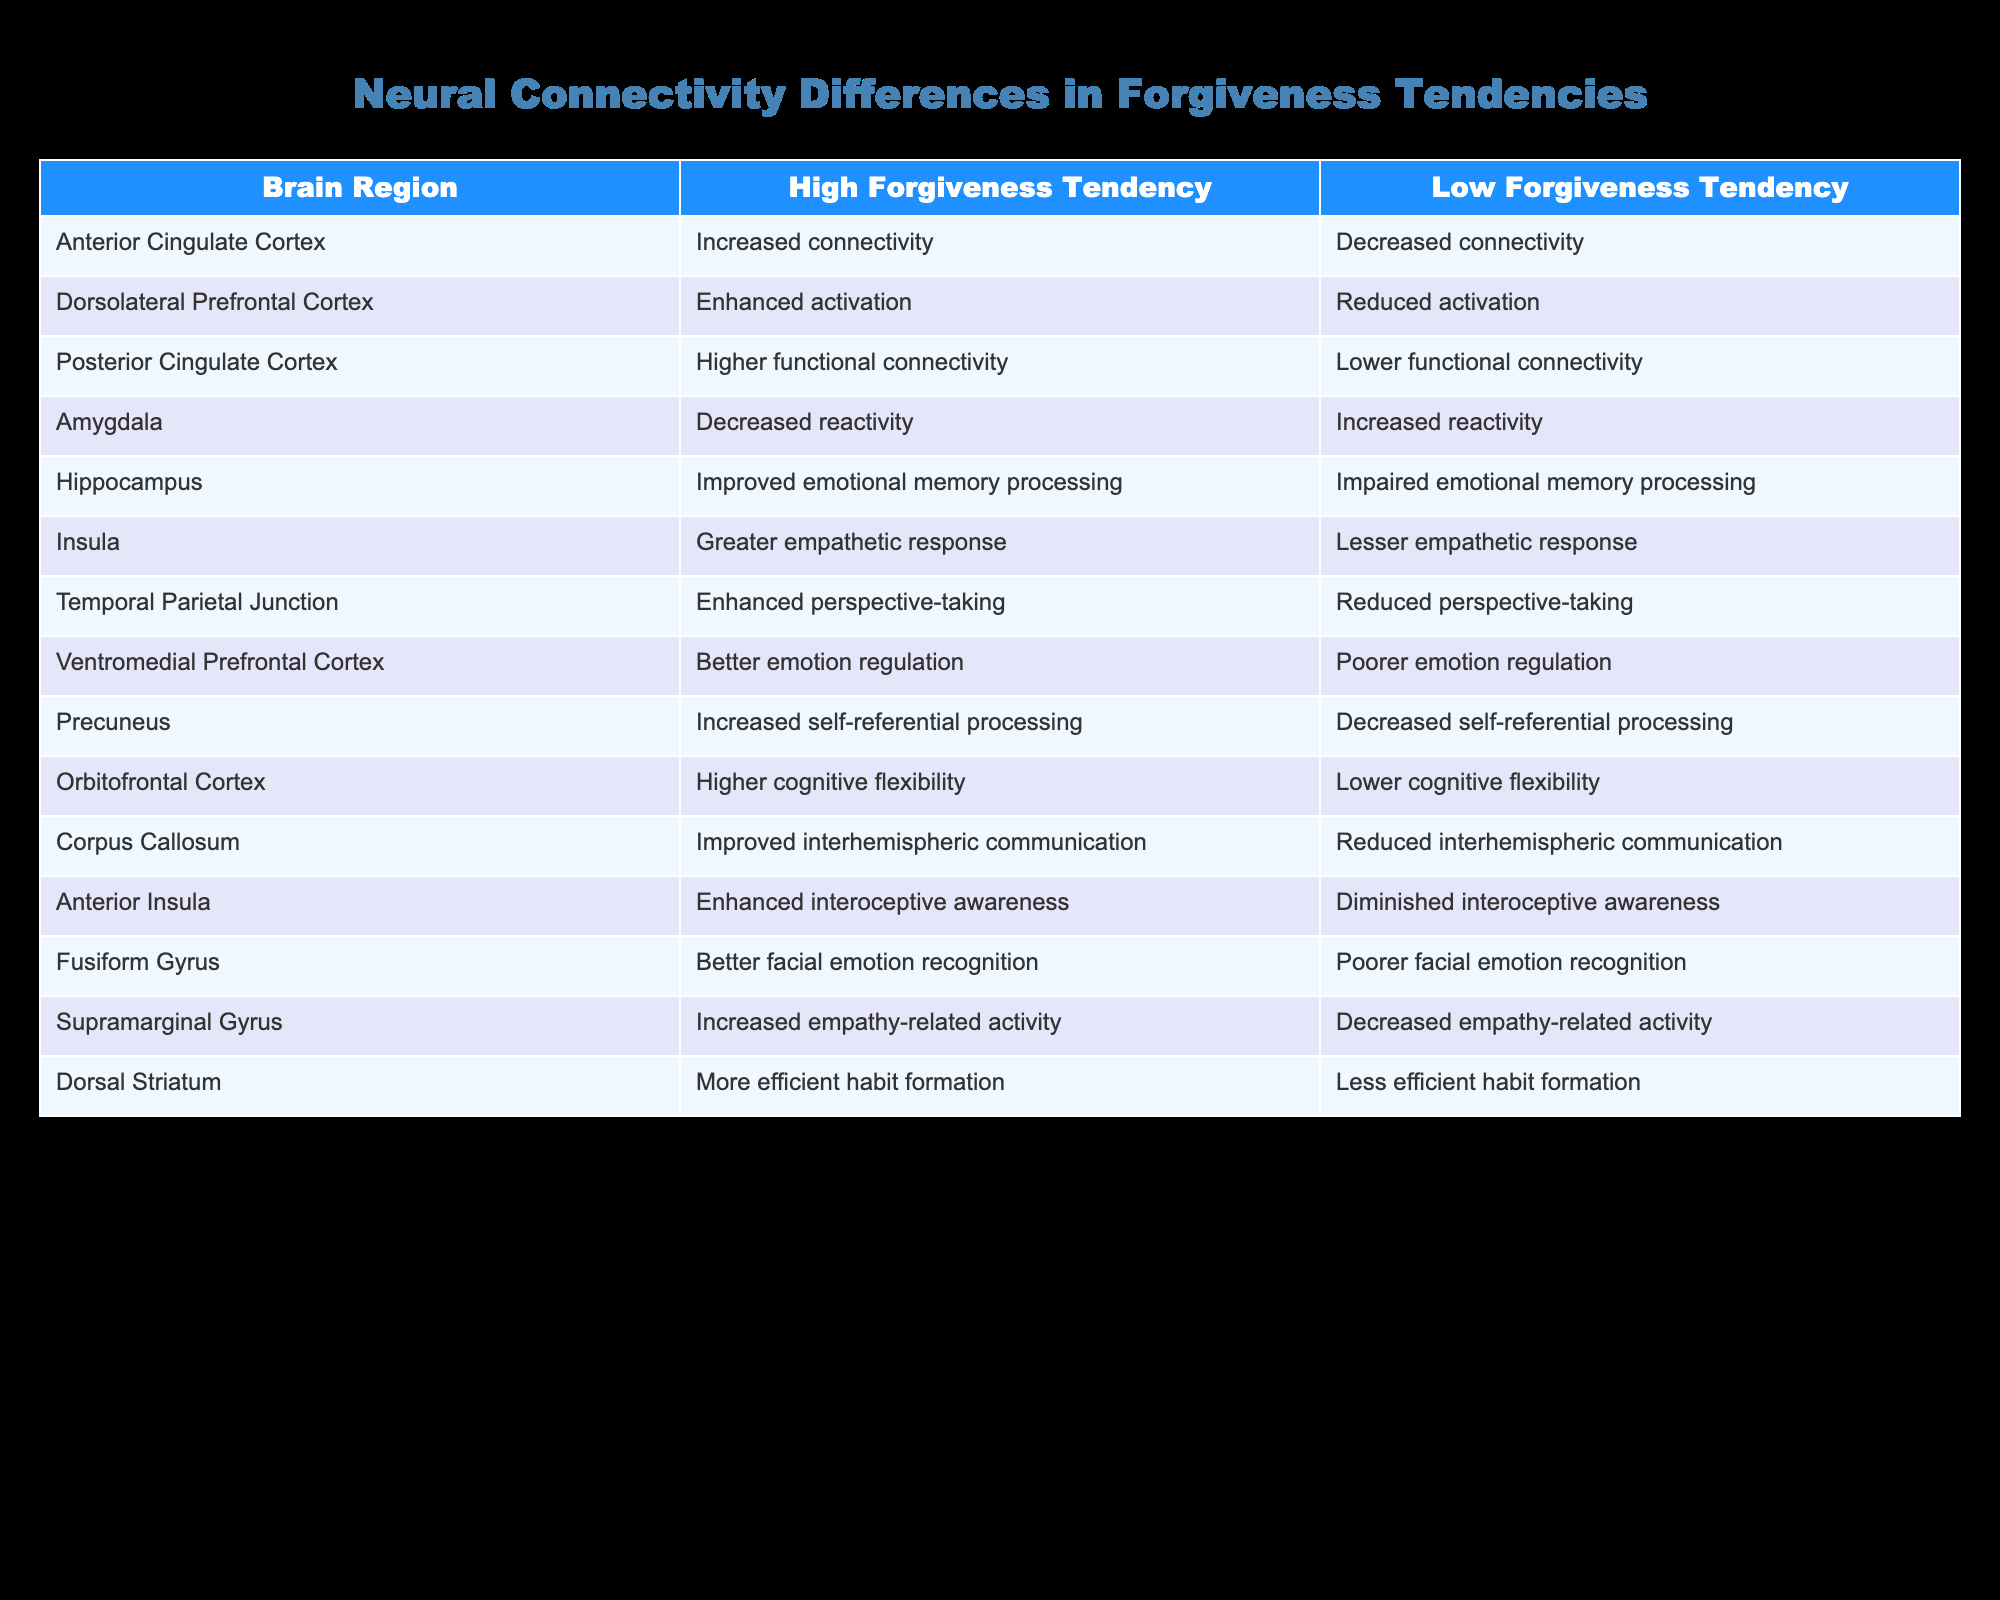What is the difference in connectivity for the Anterior Cingulate Cortex between individuals with high and low forgiveness tendencies? The table indicates that individuals with high forgiveness tendencies have increased connectivity in the Anterior Cingulate Cortex, while those with low tendencies show decreased connectivity in the same region. The difference lies in the terms "increased" versus "decreased."
Answer: Increased versus decreased Which brain region shows better emotion regulation in individuals with high forgiveness tendencies? The table states that the Ventromedial Prefrontal Cortex is associated with better emotion regulation in individuals with high forgiveness tendencies, compared to poorer emotion regulation in those with low tendencies.
Answer: Ventromedial Prefrontal Cortex Is there a brain region associated with increased empathy-related activity in individuals with high forgiveness tendencies? Yes, the Supramarginal Gyrus is linked to increased empathy-related activity in individuals with high forgiveness tendencies according to the table.
Answer: Yes How does the connectivity of the Corpus Callosum compare between individuals with high and low forgiveness tendencies? The Corpus Callosum in individuals with high forgiveness tendencies shows improved interhemispheric communication, whereas those with low tendencies show reduced interhemispheric communication. The comparison highlights the difference in levels of communication between the hemispheres.
Answer: Improved vs. reduced Which two regions show the most significant difference in emotional memory processing between the high and low forgiveness groups? The Hippocampus shows improved emotional memory processing in the high forgiveness group, while it is noted as impaired in the low forgiveness group. The contrast indicates a significant difference between the two groups. Taking the Hippocampus alone might indicate it is a critical region for emotional memory associated with forgiveness tendencies.
Answer: Hippocampus 